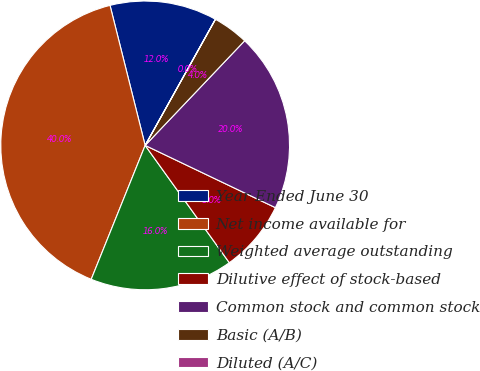Convert chart. <chart><loc_0><loc_0><loc_500><loc_500><pie_chart><fcel>Year Ended June 30<fcel>Net income available for<fcel>Weighted average outstanding<fcel>Dilutive effect of stock-based<fcel>Common stock and common stock<fcel>Basic (A/B)<fcel>Diluted (A/C)<nl><fcel>12.0%<fcel>39.99%<fcel>16.0%<fcel>8.0%<fcel>20.0%<fcel>4.0%<fcel>0.01%<nl></chart> 